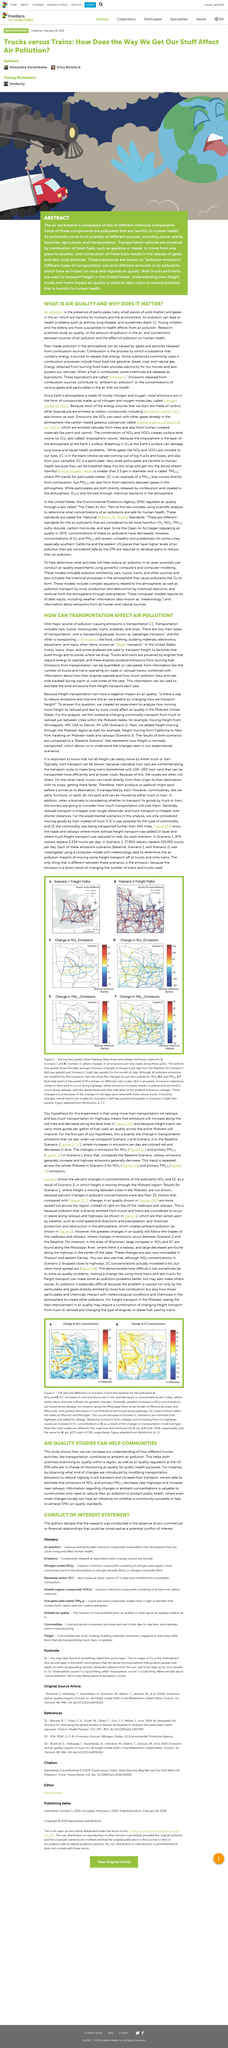List a handful of essential elements in this visual. The Earth's atmosphere is composed primarily of nitrogen and oxygen, with trace amounts of other gases. Combustion is the process by which a substance that contains energy is burned to release that energy. In general, rail transport is cheaper than truck transport over longer distances. Air pollution is the presence in the air of particulates and gases that are harmful to humans and the environment. The top two panels display red and blue lines, indicating highway and railway routes, respectively. 